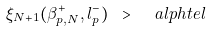Convert formula to latex. <formula><loc_0><loc_0><loc_500><loc_500>\xi _ { N + 1 } ( \beta ^ { + } _ { p , N } , l ^ { - } _ { p } ) \ > \ \ a l p h t e l</formula> 